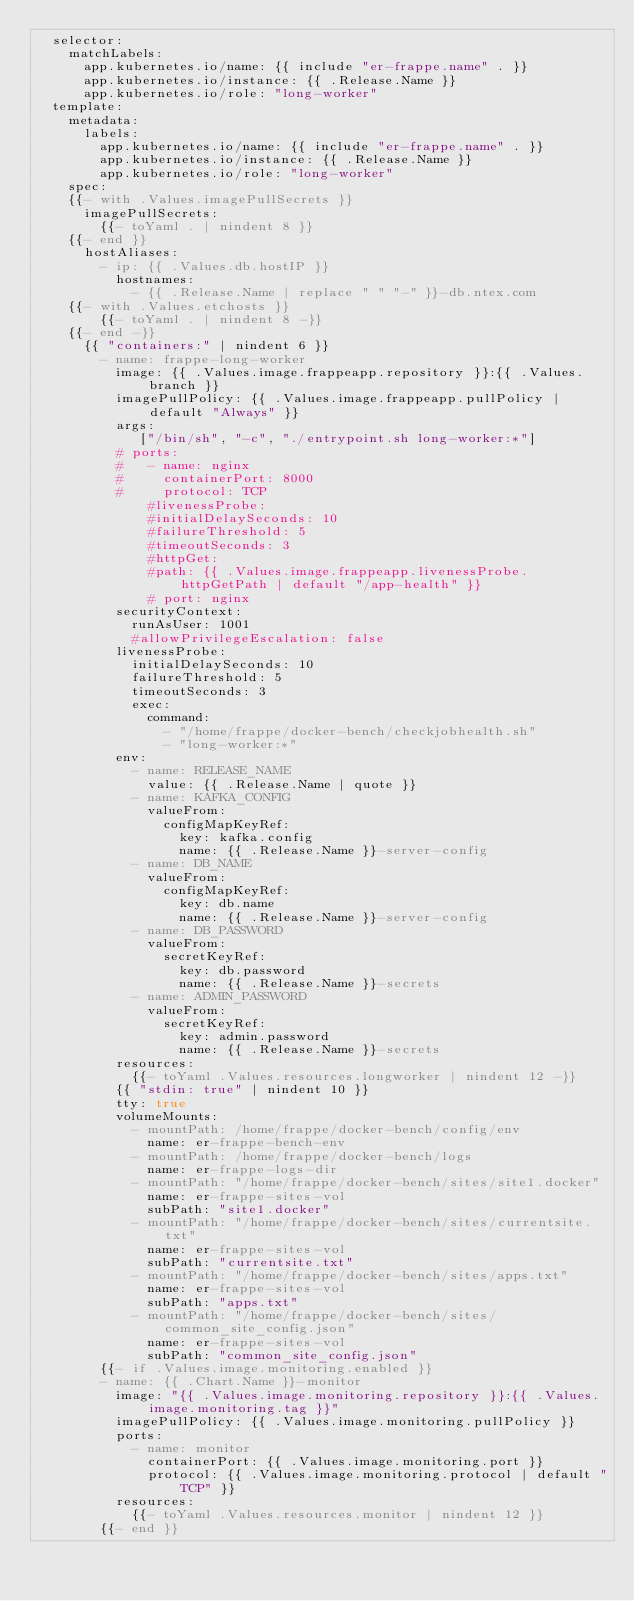Convert code to text. <code><loc_0><loc_0><loc_500><loc_500><_YAML_>  selector:
    matchLabels:
      app.kubernetes.io/name: {{ include "er-frappe.name" . }}
      app.kubernetes.io/instance: {{ .Release.Name }}
      app.kubernetes.io/role: "long-worker"
  template:
    metadata:
      labels:
        app.kubernetes.io/name: {{ include "er-frappe.name" . }}
        app.kubernetes.io/instance: {{ .Release.Name }}
        app.kubernetes.io/role: "long-worker"
    spec:
    {{- with .Values.imagePullSecrets }}
      imagePullSecrets:
        {{- toYaml . | nindent 8 }}
    {{- end }}
      hostAliases:
        - ip: {{ .Values.db.hostIP }}
          hostnames:
            - {{ .Release.Name | replace " " "-" }}-db.ntex.com
    {{- with .Values.etchosts }}
        {{- toYaml . | nindent 8 -}}
    {{- end -}}
      {{ "containers:" | nindent 6 }}
        - name: frappe-long-worker
          image: {{ .Values.image.frappeapp.repository }}:{{ .Values.branch }}
          imagePullPolicy: {{ .Values.image.frappeapp.pullPolicy | default "Always" }}
          args:
             ["/bin/sh", "-c", "./entrypoint.sh long-worker:*"]
          # ports:
          #   - name: nginx
          #     containerPort: 8000
          #     protocol: TCP
              #livenessProbe:
              #initialDelaySeconds: 10
              #failureThreshold: 5
              #timeoutSeconds: 3
              #httpGet:
              #path: {{ .Values.image.frappeapp.livenessProbe.httpGetPath | default "/app-health" }}
              # port: nginx
          securityContext:
            runAsUser: 1001
            #allowPrivilegeEscalation: false
          livenessProbe:
            initialDelaySeconds: 10
            failureThreshold: 5
            timeoutSeconds: 3
            exec:
              command:
                - "/home/frappe/docker-bench/checkjobhealth.sh"
                - "long-worker:*"
          env:
            - name: RELEASE_NAME
              value: {{ .Release.Name | quote }}
            - name: KAFKA_CONFIG
              valueFrom:
                configMapKeyRef:
                  key: kafka.config
                  name: {{ .Release.Name }}-server-config
            - name: DB_NAME
              valueFrom:
                configMapKeyRef:
                  key: db.name
                  name: {{ .Release.Name }}-server-config
            - name: DB_PASSWORD
              valueFrom:
                secretKeyRef:
                  key: db.password
                  name: {{ .Release.Name }}-secrets
            - name: ADMIN_PASSWORD
              valueFrom:
                secretKeyRef:
                  key: admin.password
                  name: {{ .Release.Name }}-secrets
          resources:
            {{- toYaml .Values.resources.longworker | nindent 12 -}}
          {{ "stdin: true" | nindent 10 }}
          tty: true
          volumeMounts:
            - mountPath: /home/frappe/docker-bench/config/env
              name: er-frappe-bench-env
            - mountPath: /home/frappe/docker-bench/logs
              name: er-frappe-logs-dir
            - mountPath: "/home/frappe/docker-bench/sites/site1.docker"
              name: er-frappe-sites-vol
              subPath: "site1.docker"
            - mountPath: "/home/frappe/docker-bench/sites/currentsite.txt"
              name: er-frappe-sites-vol
              subPath: "currentsite.txt"
            - mountPath: "/home/frappe/docker-bench/sites/apps.txt"
              name: er-frappe-sites-vol
              subPath: "apps.txt"
            - mountPath: "/home/frappe/docker-bench/sites/common_site_config.json"
              name: er-frappe-sites-vol
              subPath: "common_site_config.json"
        {{- if .Values.image.monitoring.enabled }}
        - name: {{ .Chart.Name }}-monitor
          image: "{{ .Values.image.monitoring.repository }}:{{ .Values.image.monitoring.tag }}"
          imagePullPolicy: {{ .Values.image.monitoring.pullPolicy }}
          ports:
            - name: monitor
              containerPort: {{ .Values.image.monitoring.port }}
              protocol: {{ .Values.image.monitoring.protocol | default "TCP" }}
          resources:
            {{- toYaml .Values.resources.monitor | nindent 12 }}
        {{- end }}</code> 